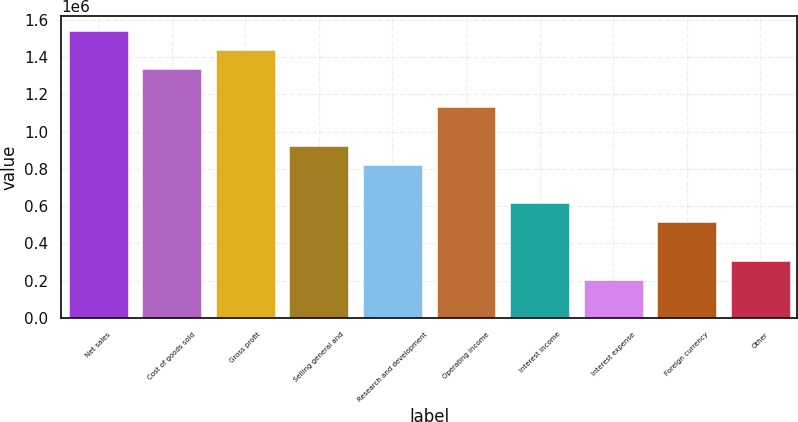Convert chart. <chart><loc_0><loc_0><loc_500><loc_500><bar_chart><fcel>Net sales<fcel>Cost of goods sold<fcel>Gross profit<fcel>Selling general and<fcel>Research and development<fcel>Operating income<fcel>Interest income<fcel>Interest expense<fcel>Foreign currency<fcel>Other<nl><fcel>1.54166e+06<fcel>1.3361e+06<fcel>1.43888e+06<fcel>924996<fcel>822219<fcel>1.13055e+06<fcel>616664<fcel>205556<fcel>513887<fcel>308333<nl></chart> 